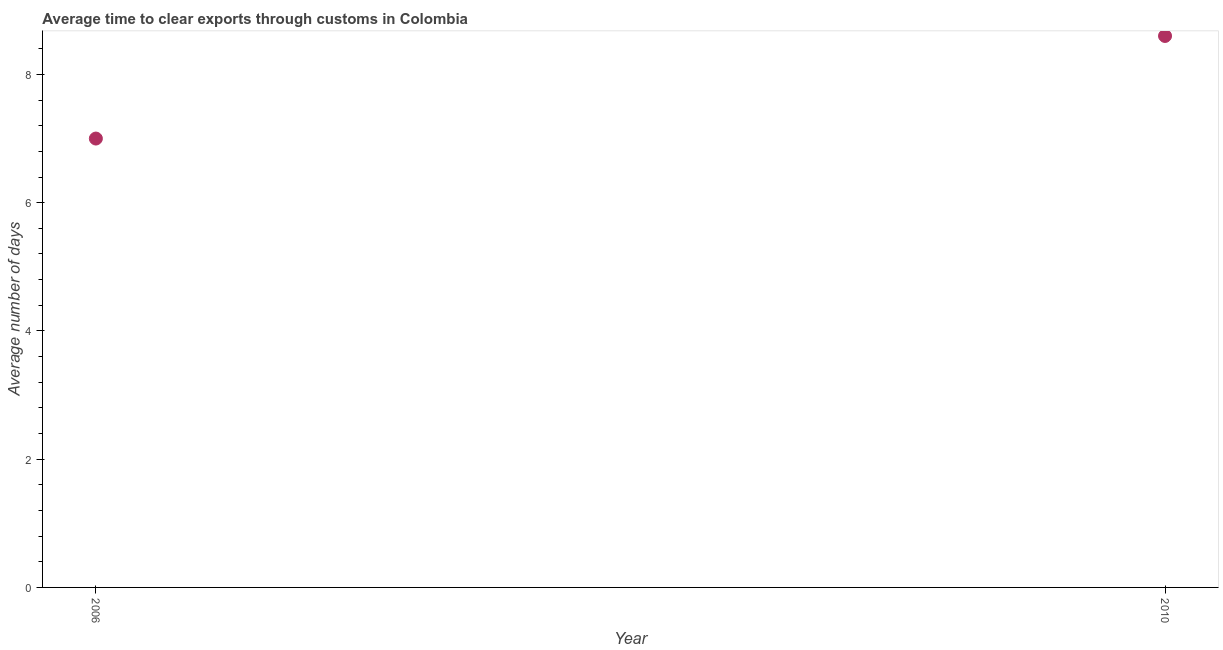What is the time to clear exports through customs in 2006?
Your response must be concise. 7. Across all years, what is the minimum time to clear exports through customs?
Ensure brevity in your answer.  7. In which year was the time to clear exports through customs maximum?
Offer a very short reply. 2010. In which year was the time to clear exports through customs minimum?
Your response must be concise. 2006. What is the difference between the time to clear exports through customs in 2006 and 2010?
Provide a succinct answer. -1.6. In how many years, is the time to clear exports through customs greater than 7.2 days?
Your answer should be compact. 1. Do a majority of the years between 2006 and 2010 (inclusive) have time to clear exports through customs greater than 2.4 days?
Provide a succinct answer. Yes. What is the ratio of the time to clear exports through customs in 2006 to that in 2010?
Provide a short and direct response. 0.81. Is the time to clear exports through customs in 2006 less than that in 2010?
Your answer should be very brief. Yes. Does the time to clear exports through customs monotonically increase over the years?
Keep it short and to the point. Yes. How many years are there in the graph?
Your response must be concise. 2. What is the title of the graph?
Provide a succinct answer. Average time to clear exports through customs in Colombia. What is the label or title of the X-axis?
Provide a short and direct response. Year. What is the label or title of the Y-axis?
Provide a short and direct response. Average number of days. What is the ratio of the Average number of days in 2006 to that in 2010?
Your answer should be very brief. 0.81. 